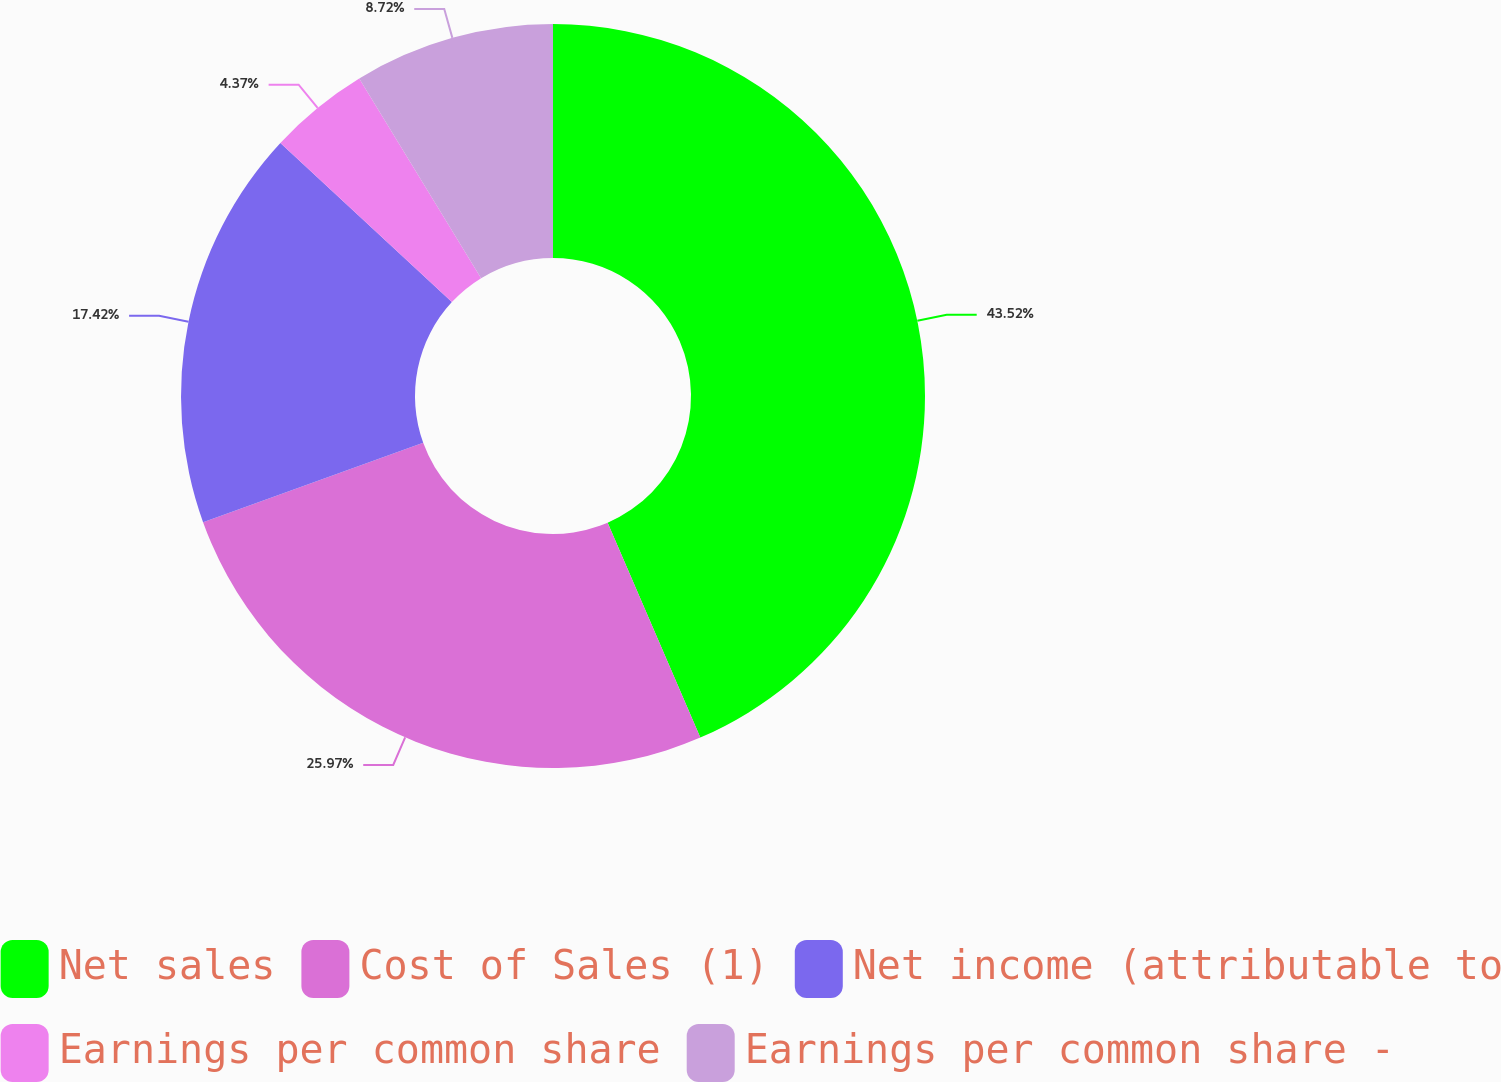<chart> <loc_0><loc_0><loc_500><loc_500><pie_chart><fcel>Net sales<fcel>Cost of Sales (1)<fcel>Net income (attributable to<fcel>Earnings per common share<fcel>Earnings per common share -<nl><fcel>43.52%<fcel>25.97%<fcel>17.42%<fcel>4.37%<fcel>8.72%<nl></chart> 